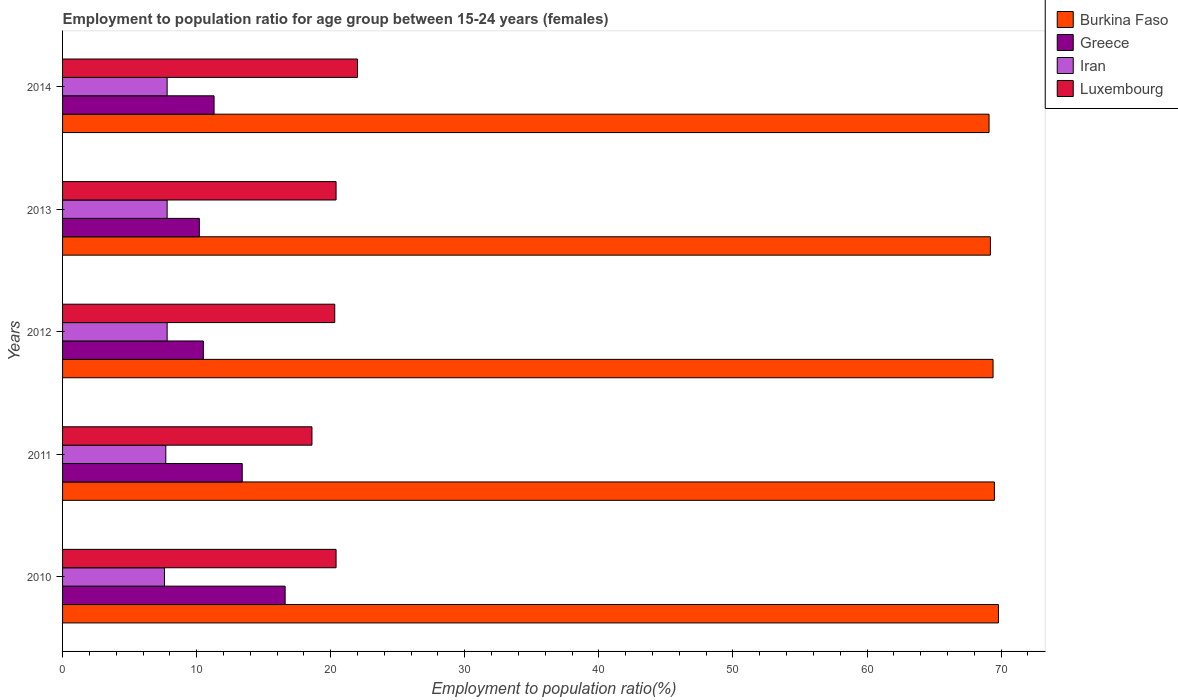How many groups of bars are there?
Your response must be concise. 5. How many bars are there on the 3rd tick from the top?
Make the answer very short. 4. How many bars are there on the 4th tick from the bottom?
Your answer should be very brief. 4. What is the label of the 4th group of bars from the top?
Provide a succinct answer. 2011. What is the employment to population ratio in Iran in 2014?
Offer a very short reply. 7.8. Across all years, what is the maximum employment to population ratio in Greece?
Your response must be concise. 16.6. Across all years, what is the minimum employment to population ratio in Iran?
Give a very brief answer. 7.6. In which year was the employment to population ratio in Greece maximum?
Keep it short and to the point. 2010. What is the total employment to population ratio in Luxembourg in the graph?
Your answer should be very brief. 101.7. What is the difference between the employment to population ratio in Greece in 2010 and that in 2012?
Provide a short and direct response. 6.1. What is the difference between the employment to population ratio in Iran in 2010 and the employment to population ratio in Luxembourg in 2012?
Make the answer very short. -12.7. What is the average employment to population ratio in Iran per year?
Ensure brevity in your answer.  7.74. In the year 2012, what is the difference between the employment to population ratio in Luxembourg and employment to population ratio in Greece?
Offer a terse response. 9.8. In how many years, is the employment to population ratio in Luxembourg greater than 24 %?
Offer a very short reply. 0. What is the ratio of the employment to population ratio in Greece in 2011 to that in 2012?
Provide a succinct answer. 1.28. Is the difference between the employment to population ratio in Luxembourg in 2010 and 2013 greater than the difference between the employment to population ratio in Greece in 2010 and 2013?
Your answer should be compact. No. What is the difference between the highest and the second highest employment to population ratio in Burkina Faso?
Offer a very short reply. 0.3. What is the difference between the highest and the lowest employment to population ratio in Greece?
Your answer should be compact. 6.4. What does the 2nd bar from the top in 2012 represents?
Ensure brevity in your answer.  Iran. What does the 1st bar from the bottom in 2011 represents?
Offer a terse response. Burkina Faso. How many bars are there?
Provide a succinct answer. 20. How many years are there in the graph?
Give a very brief answer. 5. What is the difference between two consecutive major ticks on the X-axis?
Your response must be concise. 10. Are the values on the major ticks of X-axis written in scientific E-notation?
Provide a succinct answer. No. How many legend labels are there?
Your response must be concise. 4. What is the title of the graph?
Provide a short and direct response. Employment to population ratio for age group between 15-24 years (females). What is the label or title of the X-axis?
Keep it short and to the point. Employment to population ratio(%). What is the label or title of the Y-axis?
Your answer should be very brief. Years. What is the Employment to population ratio(%) in Burkina Faso in 2010?
Keep it short and to the point. 69.8. What is the Employment to population ratio(%) of Greece in 2010?
Your answer should be very brief. 16.6. What is the Employment to population ratio(%) of Iran in 2010?
Your response must be concise. 7.6. What is the Employment to population ratio(%) in Luxembourg in 2010?
Make the answer very short. 20.4. What is the Employment to population ratio(%) of Burkina Faso in 2011?
Your answer should be very brief. 69.5. What is the Employment to population ratio(%) in Greece in 2011?
Ensure brevity in your answer.  13.4. What is the Employment to population ratio(%) in Iran in 2011?
Keep it short and to the point. 7.7. What is the Employment to population ratio(%) of Luxembourg in 2011?
Offer a very short reply. 18.6. What is the Employment to population ratio(%) in Burkina Faso in 2012?
Offer a terse response. 69.4. What is the Employment to population ratio(%) of Iran in 2012?
Provide a succinct answer. 7.8. What is the Employment to population ratio(%) of Luxembourg in 2012?
Your answer should be compact. 20.3. What is the Employment to population ratio(%) of Burkina Faso in 2013?
Make the answer very short. 69.2. What is the Employment to population ratio(%) of Greece in 2013?
Provide a succinct answer. 10.2. What is the Employment to population ratio(%) in Iran in 2013?
Keep it short and to the point. 7.8. What is the Employment to population ratio(%) in Luxembourg in 2013?
Give a very brief answer. 20.4. What is the Employment to population ratio(%) in Burkina Faso in 2014?
Your answer should be compact. 69.1. What is the Employment to population ratio(%) in Greece in 2014?
Offer a terse response. 11.3. What is the Employment to population ratio(%) of Iran in 2014?
Ensure brevity in your answer.  7.8. What is the Employment to population ratio(%) of Luxembourg in 2014?
Your answer should be very brief. 22. Across all years, what is the maximum Employment to population ratio(%) of Burkina Faso?
Your answer should be very brief. 69.8. Across all years, what is the maximum Employment to population ratio(%) of Greece?
Your response must be concise. 16.6. Across all years, what is the maximum Employment to population ratio(%) in Iran?
Offer a terse response. 7.8. Across all years, what is the maximum Employment to population ratio(%) of Luxembourg?
Keep it short and to the point. 22. Across all years, what is the minimum Employment to population ratio(%) in Burkina Faso?
Ensure brevity in your answer.  69.1. Across all years, what is the minimum Employment to population ratio(%) of Greece?
Provide a short and direct response. 10.2. Across all years, what is the minimum Employment to population ratio(%) of Iran?
Provide a succinct answer. 7.6. Across all years, what is the minimum Employment to population ratio(%) of Luxembourg?
Give a very brief answer. 18.6. What is the total Employment to population ratio(%) in Burkina Faso in the graph?
Give a very brief answer. 347. What is the total Employment to population ratio(%) of Greece in the graph?
Make the answer very short. 62. What is the total Employment to population ratio(%) of Iran in the graph?
Your answer should be compact. 38.7. What is the total Employment to population ratio(%) in Luxembourg in the graph?
Make the answer very short. 101.7. What is the difference between the Employment to population ratio(%) in Greece in 2010 and that in 2011?
Give a very brief answer. 3.2. What is the difference between the Employment to population ratio(%) in Luxembourg in 2010 and that in 2011?
Give a very brief answer. 1.8. What is the difference between the Employment to population ratio(%) of Greece in 2010 and that in 2012?
Give a very brief answer. 6.1. What is the difference between the Employment to population ratio(%) in Luxembourg in 2010 and that in 2012?
Give a very brief answer. 0.1. What is the difference between the Employment to population ratio(%) of Iran in 2010 and that in 2013?
Provide a short and direct response. -0.2. What is the difference between the Employment to population ratio(%) of Luxembourg in 2010 and that in 2013?
Make the answer very short. 0. What is the difference between the Employment to population ratio(%) in Burkina Faso in 2010 and that in 2014?
Offer a terse response. 0.7. What is the difference between the Employment to population ratio(%) in Iran in 2010 and that in 2014?
Ensure brevity in your answer.  -0.2. What is the difference between the Employment to population ratio(%) of Burkina Faso in 2011 and that in 2012?
Your response must be concise. 0.1. What is the difference between the Employment to population ratio(%) of Iran in 2011 and that in 2012?
Your answer should be very brief. -0.1. What is the difference between the Employment to population ratio(%) of Luxembourg in 2011 and that in 2012?
Provide a succinct answer. -1.7. What is the difference between the Employment to population ratio(%) in Iran in 2011 and that in 2013?
Your response must be concise. -0.1. What is the difference between the Employment to population ratio(%) of Burkina Faso in 2011 and that in 2014?
Provide a succinct answer. 0.4. What is the difference between the Employment to population ratio(%) in Luxembourg in 2012 and that in 2013?
Your answer should be compact. -0.1. What is the difference between the Employment to population ratio(%) in Burkina Faso in 2012 and that in 2014?
Give a very brief answer. 0.3. What is the difference between the Employment to population ratio(%) in Greece in 2012 and that in 2014?
Offer a very short reply. -0.8. What is the difference between the Employment to population ratio(%) in Luxembourg in 2012 and that in 2014?
Give a very brief answer. -1.7. What is the difference between the Employment to population ratio(%) of Burkina Faso in 2013 and that in 2014?
Ensure brevity in your answer.  0.1. What is the difference between the Employment to population ratio(%) of Greece in 2013 and that in 2014?
Keep it short and to the point. -1.1. What is the difference between the Employment to population ratio(%) in Luxembourg in 2013 and that in 2014?
Provide a short and direct response. -1.6. What is the difference between the Employment to population ratio(%) in Burkina Faso in 2010 and the Employment to population ratio(%) in Greece in 2011?
Make the answer very short. 56.4. What is the difference between the Employment to population ratio(%) of Burkina Faso in 2010 and the Employment to population ratio(%) of Iran in 2011?
Your response must be concise. 62.1. What is the difference between the Employment to population ratio(%) in Burkina Faso in 2010 and the Employment to population ratio(%) in Luxembourg in 2011?
Keep it short and to the point. 51.2. What is the difference between the Employment to population ratio(%) of Greece in 2010 and the Employment to population ratio(%) of Luxembourg in 2011?
Offer a very short reply. -2. What is the difference between the Employment to population ratio(%) in Iran in 2010 and the Employment to population ratio(%) in Luxembourg in 2011?
Make the answer very short. -11. What is the difference between the Employment to population ratio(%) in Burkina Faso in 2010 and the Employment to population ratio(%) in Greece in 2012?
Your answer should be compact. 59.3. What is the difference between the Employment to population ratio(%) in Burkina Faso in 2010 and the Employment to population ratio(%) in Iran in 2012?
Provide a short and direct response. 62. What is the difference between the Employment to population ratio(%) in Burkina Faso in 2010 and the Employment to population ratio(%) in Luxembourg in 2012?
Give a very brief answer. 49.5. What is the difference between the Employment to population ratio(%) in Greece in 2010 and the Employment to population ratio(%) in Luxembourg in 2012?
Make the answer very short. -3.7. What is the difference between the Employment to population ratio(%) in Iran in 2010 and the Employment to population ratio(%) in Luxembourg in 2012?
Provide a succinct answer. -12.7. What is the difference between the Employment to population ratio(%) of Burkina Faso in 2010 and the Employment to population ratio(%) of Greece in 2013?
Offer a terse response. 59.6. What is the difference between the Employment to population ratio(%) of Burkina Faso in 2010 and the Employment to population ratio(%) of Iran in 2013?
Your answer should be very brief. 62. What is the difference between the Employment to population ratio(%) of Burkina Faso in 2010 and the Employment to population ratio(%) of Luxembourg in 2013?
Your answer should be compact. 49.4. What is the difference between the Employment to population ratio(%) of Greece in 2010 and the Employment to population ratio(%) of Luxembourg in 2013?
Your response must be concise. -3.8. What is the difference between the Employment to population ratio(%) in Iran in 2010 and the Employment to population ratio(%) in Luxembourg in 2013?
Ensure brevity in your answer.  -12.8. What is the difference between the Employment to population ratio(%) in Burkina Faso in 2010 and the Employment to population ratio(%) in Greece in 2014?
Offer a very short reply. 58.5. What is the difference between the Employment to population ratio(%) of Burkina Faso in 2010 and the Employment to population ratio(%) of Luxembourg in 2014?
Ensure brevity in your answer.  47.8. What is the difference between the Employment to population ratio(%) in Greece in 2010 and the Employment to population ratio(%) in Iran in 2014?
Provide a succinct answer. 8.8. What is the difference between the Employment to population ratio(%) in Iran in 2010 and the Employment to population ratio(%) in Luxembourg in 2014?
Ensure brevity in your answer.  -14.4. What is the difference between the Employment to population ratio(%) of Burkina Faso in 2011 and the Employment to population ratio(%) of Iran in 2012?
Keep it short and to the point. 61.7. What is the difference between the Employment to population ratio(%) in Burkina Faso in 2011 and the Employment to population ratio(%) in Luxembourg in 2012?
Your response must be concise. 49.2. What is the difference between the Employment to population ratio(%) in Iran in 2011 and the Employment to population ratio(%) in Luxembourg in 2012?
Your response must be concise. -12.6. What is the difference between the Employment to population ratio(%) of Burkina Faso in 2011 and the Employment to population ratio(%) of Greece in 2013?
Keep it short and to the point. 59.3. What is the difference between the Employment to population ratio(%) in Burkina Faso in 2011 and the Employment to population ratio(%) in Iran in 2013?
Your response must be concise. 61.7. What is the difference between the Employment to population ratio(%) in Burkina Faso in 2011 and the Employment to population ratio(%) in Luxembourg in 2013?
Provide a short and direct response. 49.1. What is the difference between the Employment to population ratio(%) in Greece in 2011 and the Employment to population ratio(%) in Iran in 2013?
Give a very brief answer. 5.6. What is the difference between the Employment to population ratio(%) in Greece in 2011 and the Employment to population ratio(%) in Luxembourg in 2013?
Keep it short and to the point. -7. What is the difference between the Employment to population ratio(%) in Iran in 2011 and the Employment to population ratio(%) in Luxembourg in 2013?
Your answer should be compact. -12.7. What is the difference between the Employment to population ratio(%) in Burkina Faso in 2011 and the Employment to population ratio(%) in Greece in 2014?
Your answer should be very brief. 58.2. What is the difference between the Employment to population ratio(%) of Burkina Faso in 2011 and the Employment to population ratio(%) of Iran in 2014?
Provide a succinct answer. 61.7. What is the difference between the Employment to population ratio(%) in Burkina Faso in 2011 and the Employment to population ratio(%) in Luxembourg in 2014?
Give a very brief answer. 47.5. What is the difference between the Employment to population ratio(%) in Greece in 2011 and the Employment to population ratio(%) in Iran in 2014?
Provide a short and direct response. 5.6. What is the difference between the Employment to population ratio(%) in Iran in 2011 and the Employment to population ratio(%) in Luxembourg in 2014?
Make the answer very short. -14.3. What is the difference between the Employment to population ratio(%) of Burkina Faso in 2012 and the Employment to population ratio(%) of Greece in 2013?
Your answer should be compact. 59.2. What is the difference between the Employment to population ratio(%) in Burkina Faso in 2012 and the Employment to population ratio(%) in Iran in 2013?
Offer a very short reply. 61.6. What is the difference between the Employment to population ratio(%) of Greece in 2012 and the Employment to population ratio(%) of Iran in 2013?
Make the answer very short. 2.7. What is the difference between the Employment to population ratio(%) in Burkina Faso in 2012 and the Employment to population ratio(%) in Greece in 2014?
Give a very brief answer. 58.1. What is the difference between the Employment to population ratio(%) of Burkina Faso in 2012 and the Employment to population ratio(%) of Iran in 2014?
Your response must be concise. 61.6. What is the difference between the Employment to population ratio(%) in Burkina Faso in 2012 and the Employment to population ratio(%) in Luxembourg in 2014?
Offer a terse response. 47.4. What is the difference between the Employment to population ratio(%) in Greece in 2012 and the Employment to population ratio(%) in Iran in 2014?
Your answer should be very brief. 2.7. What is the difference between the Employment to population ratio(%) in Burkina Faso in 2013 and the Employment to population ratio(%) in Greece in 2014?
Offer a terse response. 57.9. What is the difference between the Employment to population ratio(%) in Burkina Faso in 2013 and the Employment to population ratio(%) in Iran in 2014?
Provide a succinct answer. 61.4. What is the difference between the Employment to population ratio(%) of Burkina Faso in 2013 and the Employment to population ratio(%) of Luxembourg in 2014?
Your answer should be very brief. 47.2. What is the difference between the Employment to population ratio(%) of Greece in 2013 and the Employment to population ratio(%) of Luxembourg in 2014?
Provide a short and direct response. -11.8. What is the difference between the Employment to population ratio(%) of Iran in 2013 and the Employment to population ratio(%) of Luxembourg in 2014?
Offer a terse response. -14.2. What is the average Employment to population ratio(%) in Burkina Faso per year?
Offer a terse response. 69.4. What is the average Employment to population ratio(%) of Greece per year?
Provide a short and direct response. 12.4. What is the average Employment to population ratio(%) of Iran per year?
Give a very brief answer. 7.74. What is the average Employment to population ratio(%) of Luxembourg per year?
Your answer should be compact. 20.34. In the year 2010, what is the difference between the Employment to population ratio(%) in Burkina Faso and Employment to population ratio(%) in Greece?
Make the answer very short. 53.2. In the year 2010, what is the difference between the Employment to population ratio(%) of Burkina Faso and Employment to population ratio(%) of Iran?
Offer a terse response. 62.2. In the year 2010, what is the difference between the Employment to population ratio(%) in Burkina Faso and Employment to population ratio(%) in Luxembourg?
Your response must be concise. 49.4. In the year 2010, what is the difference between the Employment to population ratio(%) in Greece and Employment to population ratio(%) in Iran?
Your response must be concise. 9. In the year 2011, what is the difference between the Employment to population ratio(%) in Burkina Faso and Employment to population ratio(%) in Greece?
Provide a short and direct response. 56.1. In the year 2011, what is the difference between the Employment to population ratio(%) in Burkina Faso and Employment to population ratio(%) in Iran?
Offer a terse response. 61.8. In the year 2011, what is the difference between the Employment to population ratio(%) in Burkina Faso and Employment to population ratio(%) in Luxembourg?
Offer a very short reply. 50.9. In the year 2011, what is the difference between the Employment to population ratio(%) in Iran and Employment to population ratio(%) in Luxembourg?
Offer a terse response. -10.9. In the year 2012, what is the difference between the Employment to population ratio(%) in Burkina Faso and Employment to population ratio(%) in Greece?
Make the answer very short. 58.9. In the year 2012, what is the difference between the Employment to population ratio(%) of Burkina Faso and Employment to population ratio(%) of Iran?
Offer a very short reply. 61.6. In the year 2012, what is the difference between the Employment to population ratio(%) of Burkina Faso and Employment to population ratio(%) of Luxembourg?
Ensure brevity in your answer.  49.1. In the year 2013, what is the difference between the Employment to population ratio(%) of Burkina Faso and Employment to population ratio(%) of Iran?
Offer a very short reply. 61.4. In the year 2013, what is the difference between the Employment to population ratio(%) in Burkina Faso and Employment to population ratio(%) in Luxembourg?
Ensure brevity in your answer.  48.8. In the year 2013, what is the difference between the Employment to population ratio(%) in Greece and Employment to population ratio(%) in Iran?
Ensure brevity in your answer.  2.4. In the year 2013, what is the difference between the Employment to population ratio(%) of Greece and Employment to population ratio(%) of Luxembourg?
Ensure brevity in your answer.  -10.2. In the year 2013, what is the difference between the Employment to population ratio(%) in Iran and Employment to population ratio(%) in Luxembourg?
Give a very brief answer. -12.6. In the year 2014, what is the difference between the Employment to population ratio(%) of Burkina Faso and Employment to population ratio(%) of Greece?
Offer a very short reply. 57.8. In the year 2014, what is the difference between the Employment to population ratio(%) of Burkina Faso and Employment to population ratio(%) of Iran?
Make the answer very short. 61.3. In the year 2014, what is the difference between the Employment to population ratio(%) in Burkina Faso and Employment to population ratio(%) in Luxembourg?
Offer a very short reply. 47.1. In the year 2014, what is the difference between the Employment to population ratio(%) of Greece and Employment to population ratio(%) of Luxembourg?
Your answer should be compact. -10.7. What is the ratio of the Employment to population ratio(%) in Burkina Faso in 2010 to that in 2011?
Offer a terse response. 1. What is the ratio of the Employment to population ratio(%) of Greece in 2010 to that in 2011?
Your answer should be compact. 1.24. What is the ratio of the Employment to population ratio(%) in Luxembourg in 2010 to that in 2011?
Keep it short and to the point. 1.1. What is the ratio of the Employment to population ratio(%) of Greece in 2010 to that in 2012?
Ensure brevity in your answer.  1.58. What is the ratio of the Employment to population ratio(%) in Iran in 2010 to that in 2012?
Make the answer very short. 0.97. What is the ratio of the Employment to population ratio(%) in Luxembourg in 2010 to that in 2012?
Provide a succinct answer. 1. What is the ratio of the Employment to population ratio(%) in Burkina Faso in 2010 to that in 2013?
Your answer should be very brief. 1.01. What is the ratio of the Employment to population ratio(%) of Greece in 2010 to that in 2013?
Ensure brevity in your answer.  1.63. What is the ratio of the Employment to population ratio(%) of Iran in 2010 to that in 2013?
Ensure brevity in your answer.  0.97. What is the ratio of the Employment to population ratio(%) of Burkina Faso in 2010 to that in 2014?
Make the answer very short. 1.01. What is the ratio of the Employment to population ratio(%) in Greece in 2010 to that in 2014?
Make the answer very short. 1.47. What is the ratio of the Employment to population ratio(%) of Iran in 2010 to that in 2014?
Make the answer very short. 0.97. What is the ratio of the Employment to population ratio(%) in Luxembourg in 2010 to that in 2014?
Your answer should be compact. 0.93. What is the ratio of the Employment to population ratio(%) in Greece in 2011 to that in 2012?
Offer a very short reply. 1.28. What is the ratio of the Employment to population ratio(%) of Iran in 2011 to that in 2012?
Your response must be concise. 0.99. What is the ratio of the Employment to population ratio(%) of Luxembourg in 2011 to that in 2012?
Provide a succinct answer. 0.92. What is the ratio of the Employment to population ratio(%) in Greece in 2011 to that in 2013?
Offer a terse response. 1.31. What is the ratio of the Employment to population ratio(%) in Iran in 2011 to that in 2013?
Provide a succinct answer. 0.99. What is the ratio of the Employment to population ratio(%) in Luxembourg in 2011 to that in 2013?
Your answer should be compact. 0.91. What is the ratio of the Employment to population ratio(%) of Burkina Faso in 2011 to that in 2014?
Your answer should be compact. 1.01. What is the ratio of the Employment to population ratio(%) in Greece in 2011 to that in 2014?
Provide a succinct answer. 1.19. What is the ratio of the Employment to population ratio(%) in Iran in 2011 to that in 2014?
Your answer should be very brief. 0.99. What is the ratio of the Employment to population ratio(%) of Luxembourg in 2011 to that in 2014?
Provide a short and direct response. 0.85. What is the ratio of the Employment to population ratio(%) of Greece in 2012 to that in 2013?
Your response must be concise. 1.03. What is the ratio of the Employment to population ratio(%) in Burkina Faso in 2012 to that in 2014?
Give a very brief answer. 1. What is the ratio of the Employment to population ratio(%) in Greece in 2012 to that in 2014?
Provide a succinct answer. 0.93. What is the ratio of the Employment to population ratio(%) in Luxembourg in 2012 to that in 2014?
Make the answer very short. 0.92. What is the ratio of the Employment to population ratio(%) in Greece in 2013 to that in 2014?
Offer a terse response. 0.9. What is the ratio of the Employment to population ratio(%) of Luxembourg in 2013 to that in 2014?
Keep it short and to the point. 0.93. What is the difference between the highest and the second highest Employment to population ratio(%) of Greece?
Your answer should be compact. 3.2. What is the difference between the highest and the lowest Employment to population ratio(%) of Burkina Faso?
Offer a terse response. 0.7. What is the difference between the highest and the lowest Employment to population ratio(%) in Greece?
Keep it short and to the point. 6.4. What is the difference between the highest and the lowest Employment to population ratio(%) in Iran?
Offer a terse response. 0.2. What is the difference between the highest and the lowest Employment to population ratio(%) in Luxembourg?
Provide a short and direct response. 3.4. 